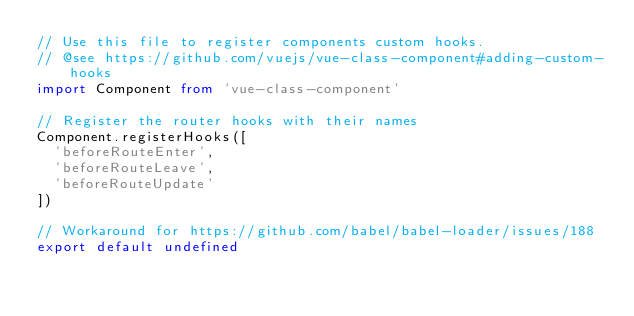<code> <loc_0><loc_0><loc_500><loc_500><_TypeScript_>// Use this file to register components custom hooks.
// @see https://github.com/vuejs/vue-class-component#adding-custom-hooks
import Component from 'vue-class-component'

// Register the router hooks with their names
Component.registerHooks([
  'beforeRouteEnter',
  'beforeRouteLeave',
  'beforeRouteUpdate'
])

// Workaround for https://github.com/babel/babel-loader/issues/188
export default undefined
</code> 